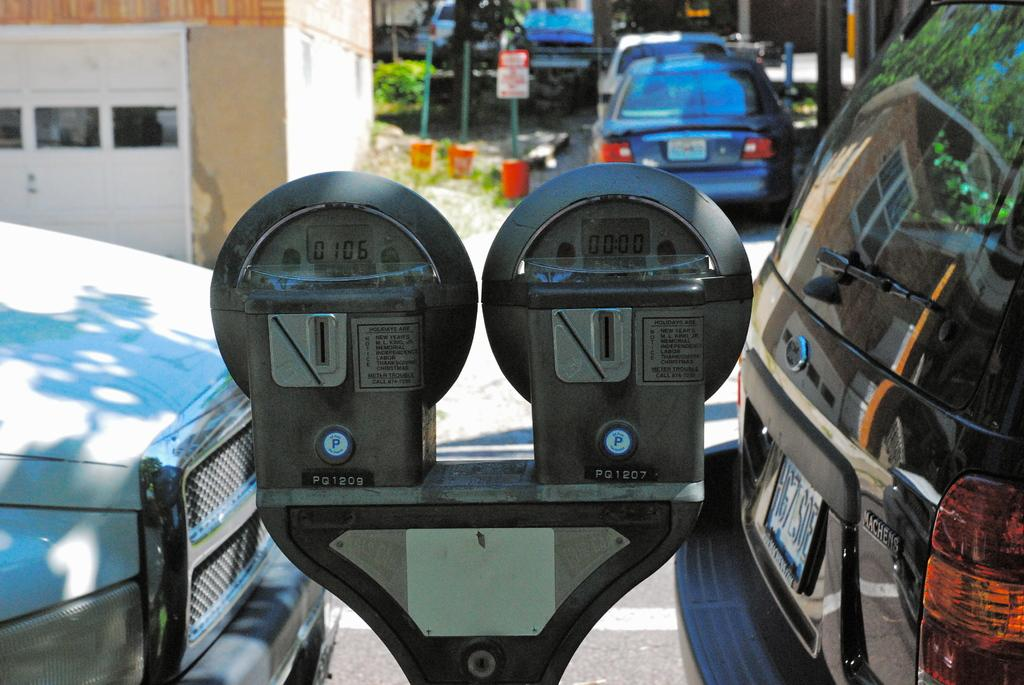Provide a one-sentence caption for the provided image. Two adjoining parking meters are labeled PQ1209 and PQ1207. 